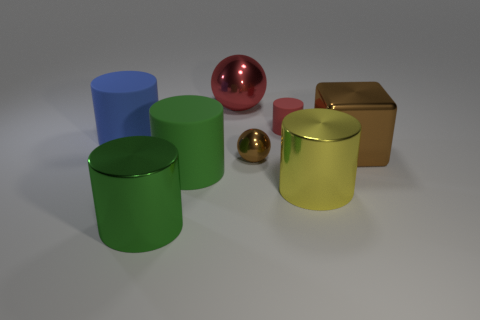The large shiny object that is both to the left of the small red object and in front of the large blue thing is what color?
Ensure brevity in your answer.  Green. Is the number of big rubber objects in front of the tiny red thing less than the number of big cylinders that are to the left of the red shiny object?
Ensure brevity in your answer.  Yes. How many other small things are the same shape as the blue object?
Give a very brief answer. 1. The brown ball that is the same material as the brown block is what size?
Make the answer very short. Small. What color is the shiny ball that is to the left of the metal ball that is in front of the large brown metal cube?
Offer a very short reply. Red. There is a small red thing; is its shape the same as the shiny object on the left side of the red sphere?
Ensure brevity in your answer.  Yes. How many red objects have the same size as the brown sphere?
Your answer should be compact. 1. What material is the yellow object that is the same shape as the green matte thing?
Your answer should be compact. Metal. There is a ball that is behind the small red thing; does it have the same color as the tiny cylinder that is to the left of the brown cube?
Your answer should be very brief. Yes. What shape is the large rubber thing behind the green matte cylinder?
Keep it short and to the point. Cylinder. 